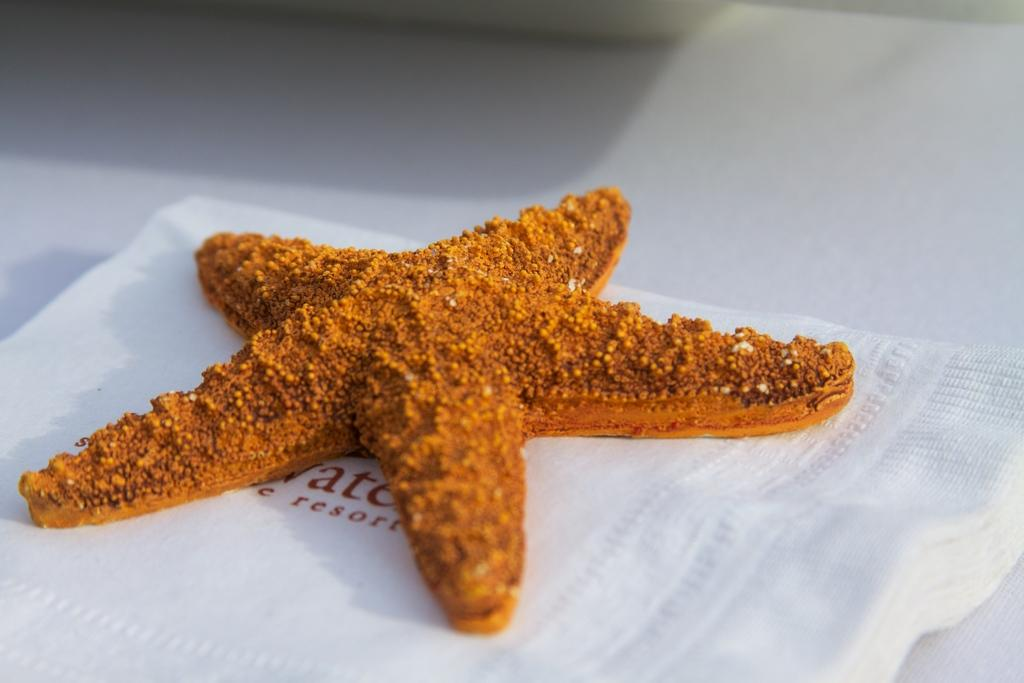What color is the food in the image? The food in the image is brown-colored. How are the brown-colored food items arranged in the image? The food is on tissues. What is the color of the surface on which the tissues are placed? The surface is white-colored. What type of operation is being performed on the tooth in the image? There is no tooth or operation present in the image; it only features brown-colored food on tissues placed on a white surface. 